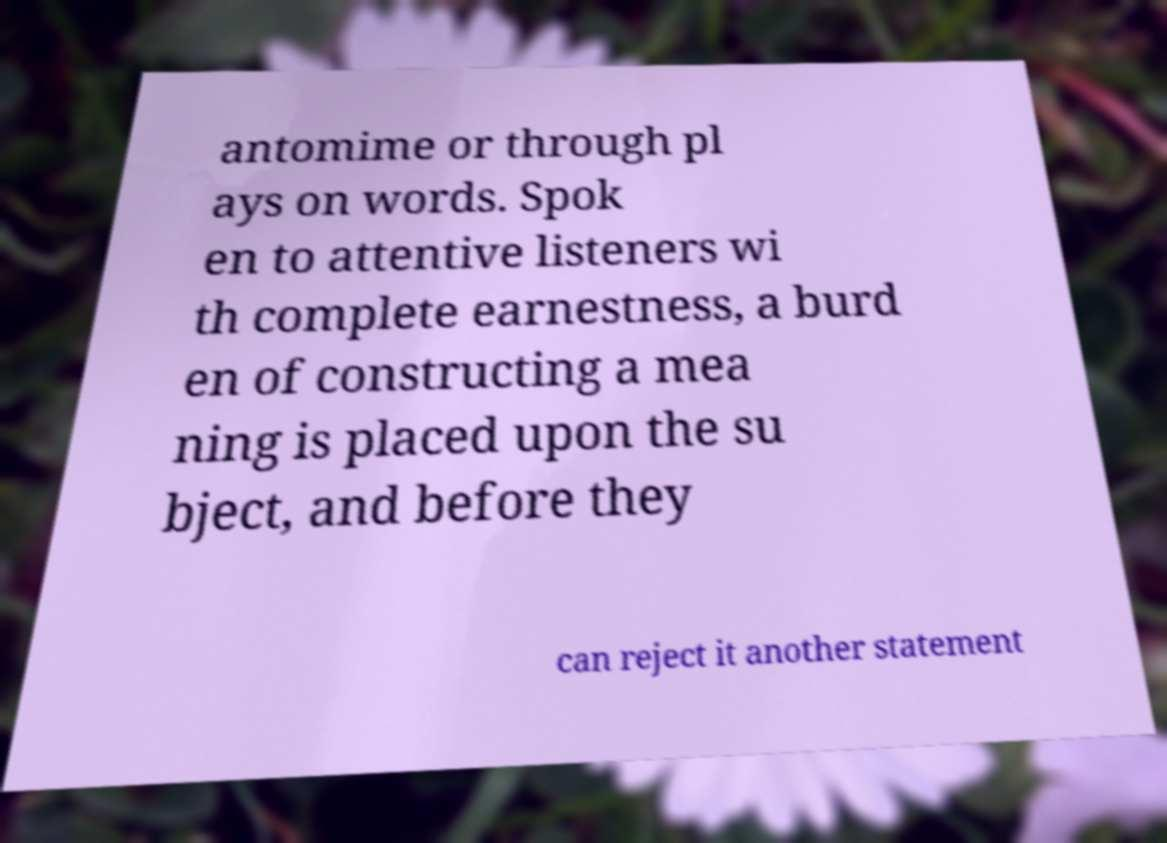Could you assist in decoding the text presented in this image and type it out clearly? antomime or through pl ays on words. Spok en to attentive listeners wi th complete earnestness, a burd en of constructing a mea ning is placed upon the su bject, and before they can reject it another statement 